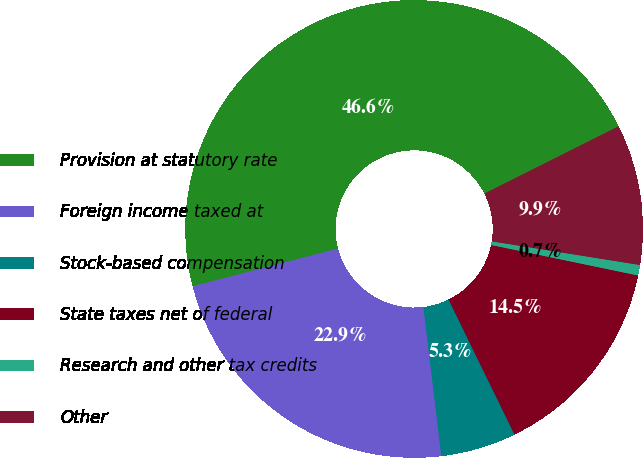Convert chart to OTSL. <chart><loc_0><loc_0><loc_500><loc_500><pie_chart><fcel>Provision at statutory rate<fcel>Foreign income taxed at<fcel>Stock-based compensation<fcel>State taxes net of federal<fcel>Research and other tax credits<fcel>Other<nl><fcel>46.63%<fcel>22.87%<fcel>5.33%<fcel>14.51%<fcel>0.74%<fcel>9.92%<nl></chart> 